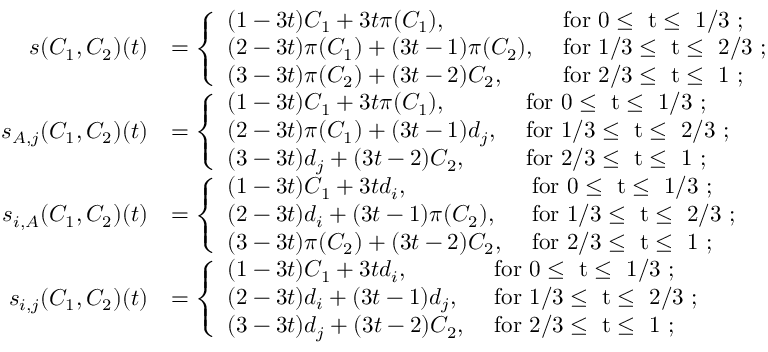Convert formula to latex. <formula><loc_0><loc_0><loc_500><loc_500>\begin{array} { r l } { s ( C _ { 1 } , C _ { 2 } ) ( t ) } & { = \left \{ \begin{array} { l l } { ( 1 - 3 t ) C _ { 1 } + 3 t \pi ( C _ { 1 } ) , } & { f o r 0 \leq t \leq 1 / 3 ; } \\ { ( 2 - 3 t ) \pi ( C _ { 1 } ) + ( 3 t - 1 ) \pi ( C _ { 2 } ) , } & { f o r 1 / 3 \leq t \leq 2 / 3 ; } \\ { ( 3 - 3 t ) \pi ( C _ { 2 } ) + ( 3 t - 2 ) C _ { 2 } , } & { f o r 2 / 3 \leq t \leq 1 ; } \end{array} } \\ { s _ { A , j } ( C _ { 1 } , C _ { 2 } ) ( t ) } & { = \left \{ \begin{array} { l l } { ( 1 - 3 t ) C _ { 1 } + 3 t \pi ( C _ { 1 } ) , } & { f o r 0 \leq t \leq 1 / 3 ; } \\ { ( 2 - 3 t ) \pi ( C _ { 1 } ) + ( 3 t - 1 ) d _ { j } , } & { f o r 1 / 3 \leq t \leq 2 / 3 ; } \\ { ( 3 - 3 t ) d _ { j } + ( 3 t - 2 ) C _ { 2 } , } & { f o r 2 / 3 \leq t \leq 1 ; } \end{array} } \\ { s _ { i , A } ( C _ { 1 } , C _ { 2 } ) ( t ) } & { = \left \{ \begin{array} { l l } { ( 1 - 3 t ) C _ { 1 } + 3 t d _ { i } , } & { f o r 0 \leq t \leq 1 / 3 ; } \\ { ( 2 - 3 t ) d _ { i } + ( 3 t - 1 ) \pi ( C _ { 2 } ) , } & { f o r 1 / 3 \leq t \leq 2 / 3 ; } \\ { ( 3 - 3 t ) \pi ( C _ { 2 } ) + ( 3 t - 2 ) C _ { 2 } , } & { f o r 2 / 3 \leq t \leq 1 ; } \end{array} } \\ { s _ { i , j } ( C _ { 1 } , C _ { 2 } ) ( t ) } & { = \left \{ \begin{array} { l l } { ( 1 - 3 t ) C _ { 1 } + 3 t d _ { i } , } & { f o r 0 \leq t \leq 1 / 3 ; } \\ { ( 2 - 3 t ) d _ { i } + ( 3 t - 1 ) d _ { j } , } & { f o r 1 / 3 \leq t \leq 2 / 3 ; } \\ { ( 3 - 3 t ) d _ { j } + ( 3 t - 2 ) C _ { 2 } , } & { f o r 2 / 3 \leq t \leq 1 ; } \end{array} } \end{array}</formula> 